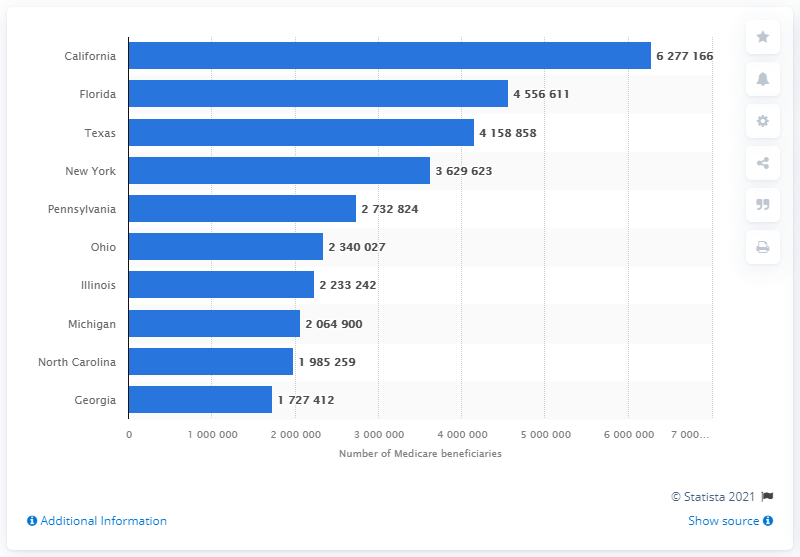Highlight a few significant elements in this photo. In 2019, there were approximately 62,771,666 Medicare beneficiaries living in the state of California. 